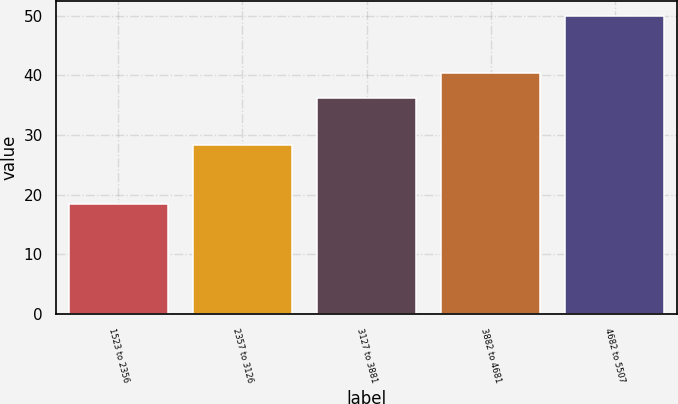<chart> <loc_0><loc_0><loc_500><loc_500><bar_chart><fcel>1523 to 2356<fcel>2357 to 3126<fcel>3127 to 3881<fcel>3882 to 4681<fcel>4682 to 5507<nl><fcel>18.42<fcel>28.33<fcel>36.25<fcel>40.35<fcel>50.01<nl></chart> 